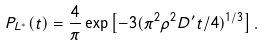Convert formula to latex. <formula><loc_0><loc_0><loc_500><loc_500>P _ { L ^ { * } } ( t ) = \frac { 4 } { \pi } \exp \left [ - 3 ( \pi ^ { 2 } \rho ^ { 2 } D ^ { \prime } t / 4 ) ^ { 1 / 3 } \right ] .</formula> 